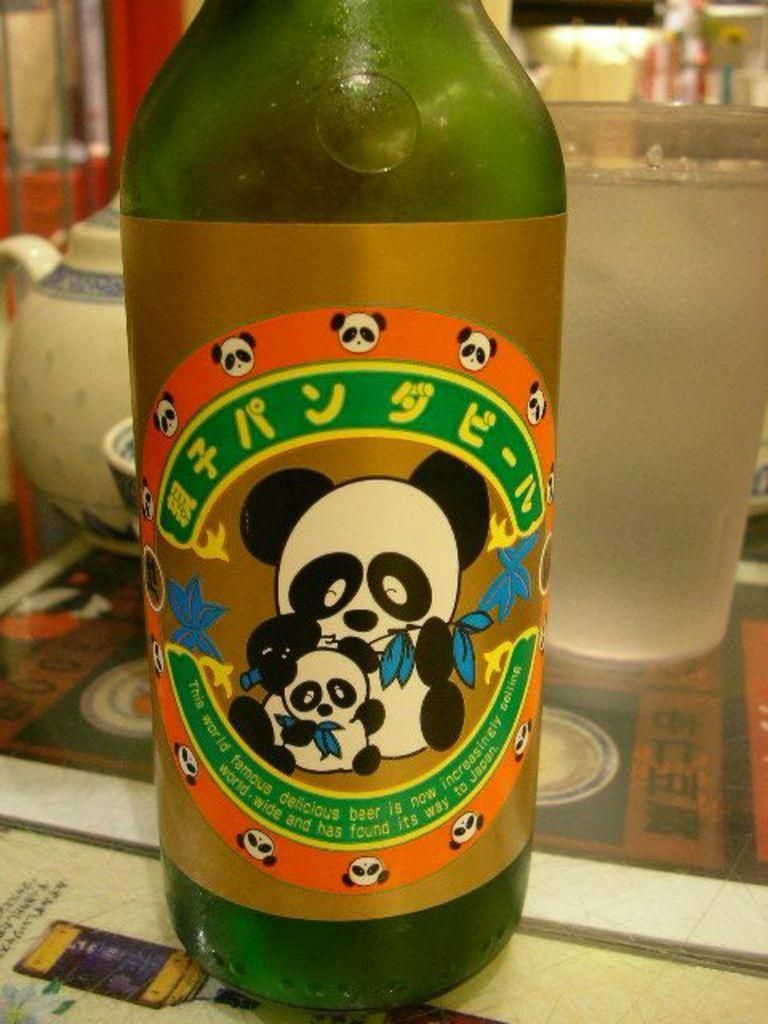What is on the table in the image? There is a green bottle on the table. Can you describe the object behind the green bottle? There is a glass behind the green bottle. What type of slope can be seen in the image? There is no slope present in the image. How does the cabbage rub against the green bottle in the image? There is no cabbage present in the image, so it cannot rub against the green bottle. 